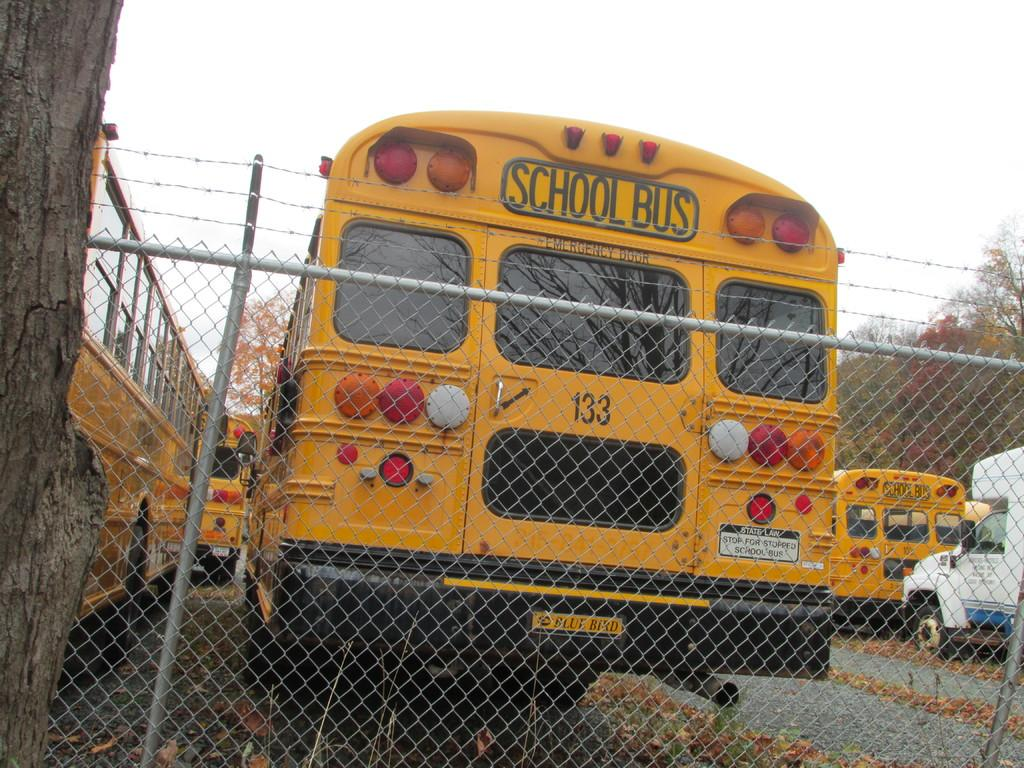<image>
Relay a brief, clear account of the picture shown. School buses in a fenced in yard with a tree. 